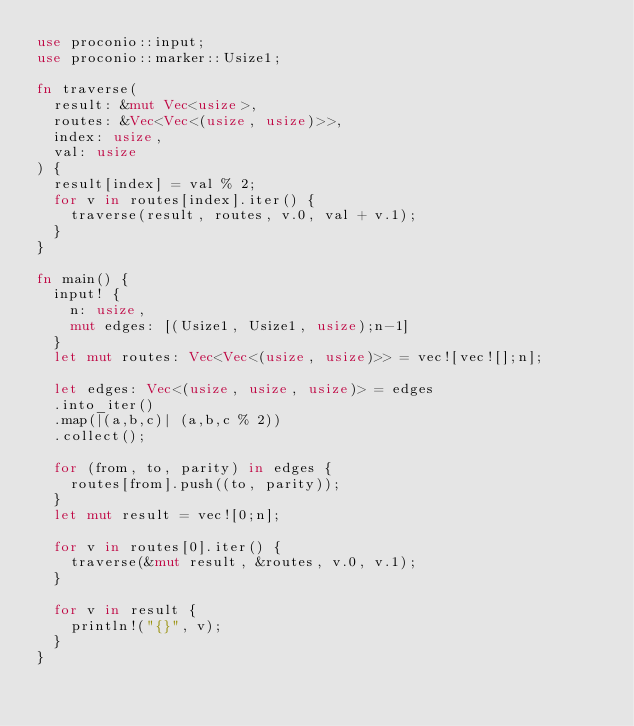<code> <loc_0><loc_0><loc_500><loc_500><_Rust_>use proconio::input;
use proconio::marker::Usize1;

fn traverse(
  result: &mut Vec<usize>,
  routes: &Vec<Vec<(usize, usize)>>,
  index: usize,
  val: usize
) {
  result[index] = val % 2;
  for v in routes[index].iter() {
    traverse(result, routes, v.0, val + v.1);
  }
}

fn main() {
  input! {
    n: usize,
    mut edges: [(Usize1, Usize1, usize);n-1]
  }
  let mut routes: Vec<Vec<(usize, usize)>> = vec![vec![];n];
  
  let edges: Vec<(usize, usize, usize)> = edges
  .into_iter()
  .map(|(a,b,c)| (a,b,c % 2))
  .collect();
  
  for (from, to, parity) in edges {
    routes[from].push((to, parity));
  }
  let mut result = vec![0;n];
  
  for v in routes[0].iter() {
    traverse(&mut result, &routes, v.0, v.1);
  }
  
  for v in result {
    println!("{}", v);
  }
}</code> 